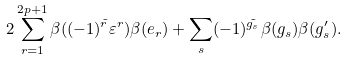<formula> <loc_0><loc_0><loc_500><loc_500>2 \sum _ { r = 1 } ^ { 2 p + 1 } \beta ( ( - 1 ) ^ { \tilde { r } } \varepsilon ^ { r } ) \beta ( e _ { r } ) + \sum _ { s } ( - 1 ) ^ { \tilde { g _ { s } } } \beta ( g _ { s } ) \beta ( g ^ { \prime } _ { s } ) .</formula> 